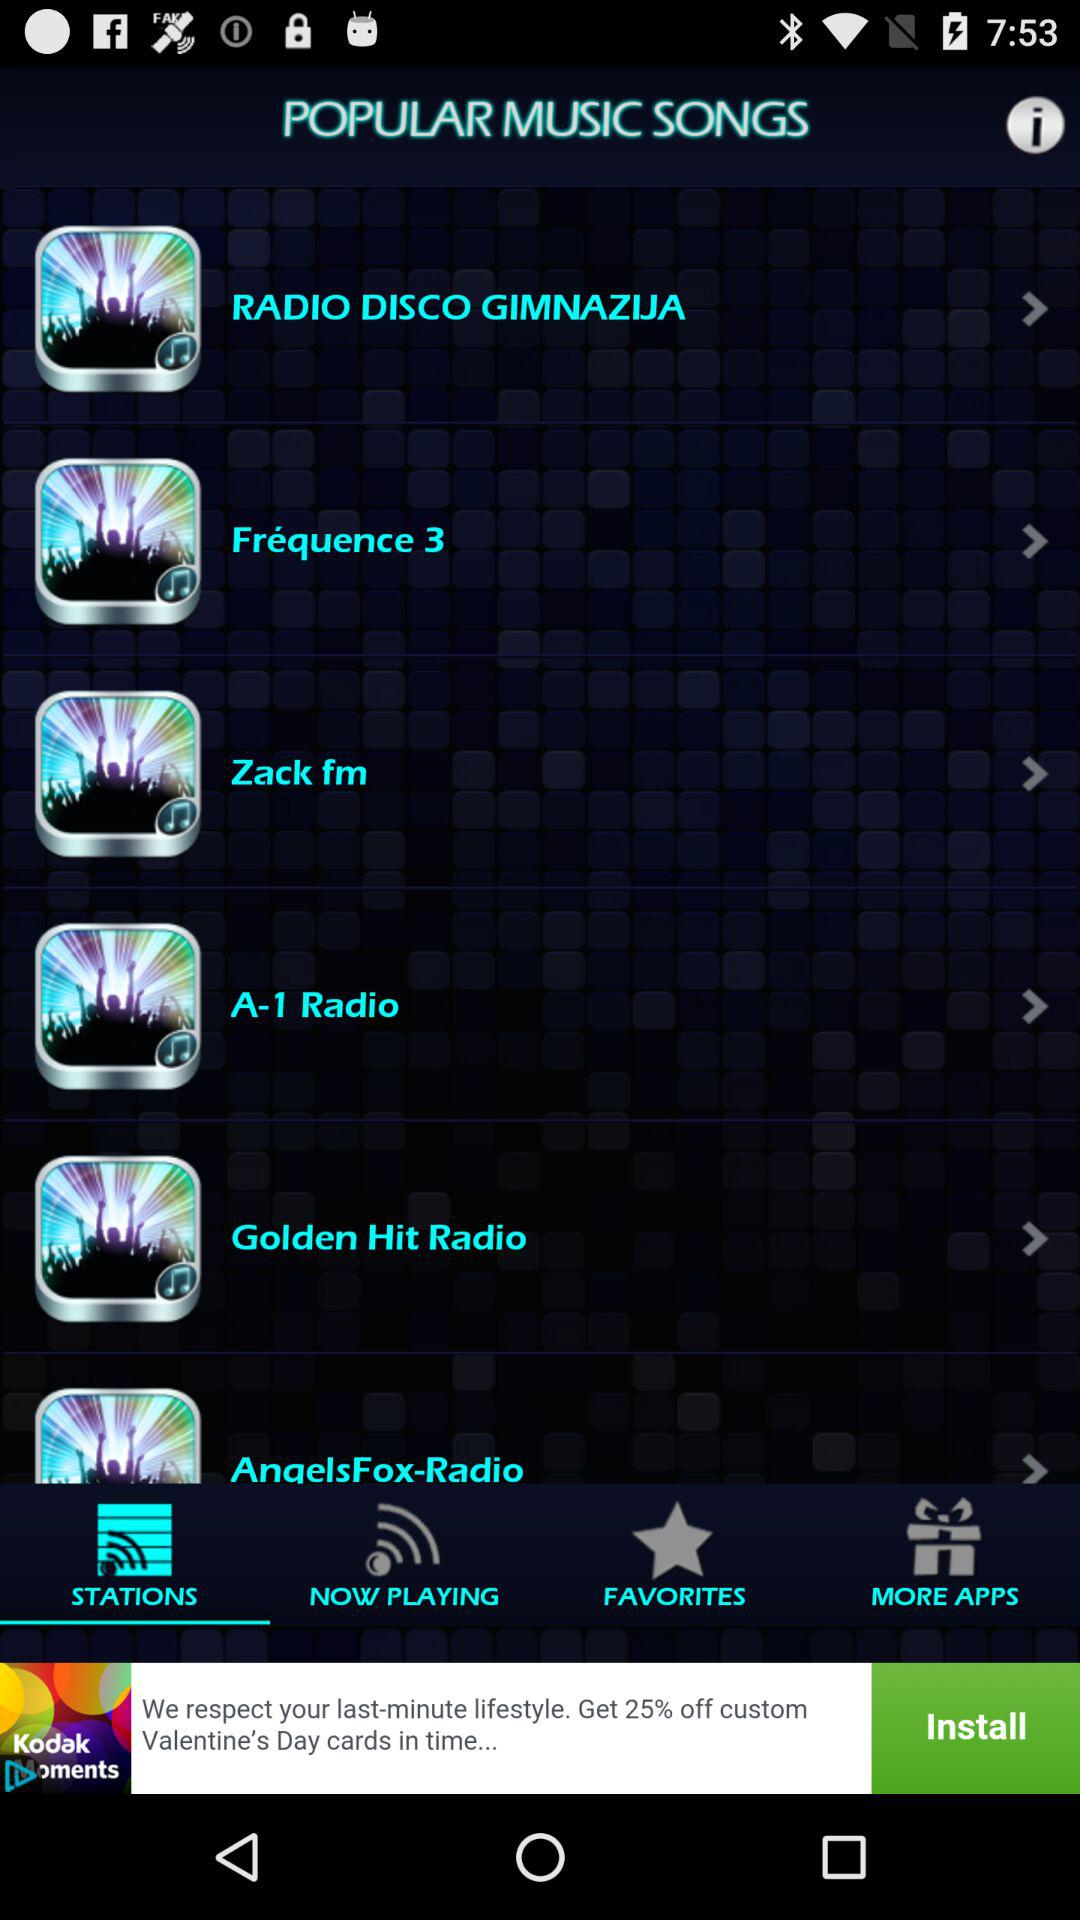Which tab is selected? The selected tab is "STATIONS". 